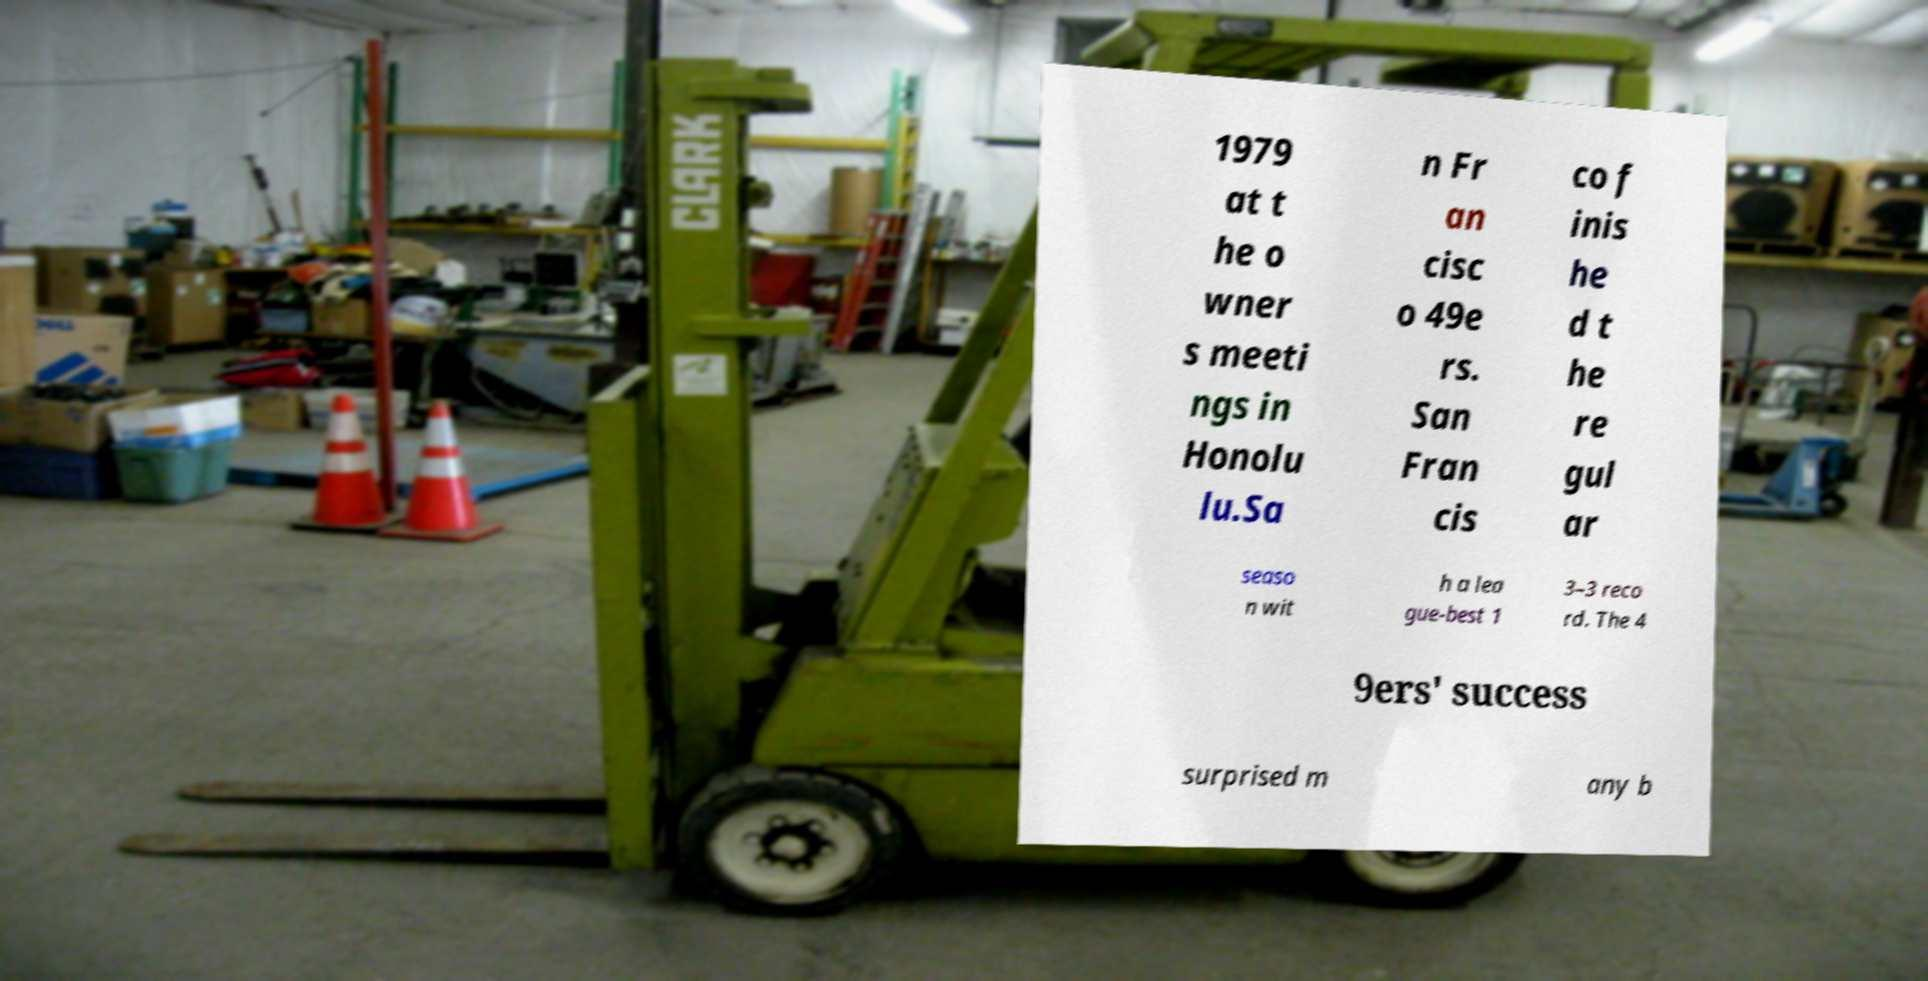What messages or text are displayed in this image? I need them in a readable, typed format. 1979 at t he o wner s meeti ngs in Honolu lu.Sa n Fr an cisc o 49e rs. San Fran cis co f inis he d t he re gul ar seaso n wit h a lea gue-best 1 3–3 reco rd. The 4 9ers' success surprised m any b 